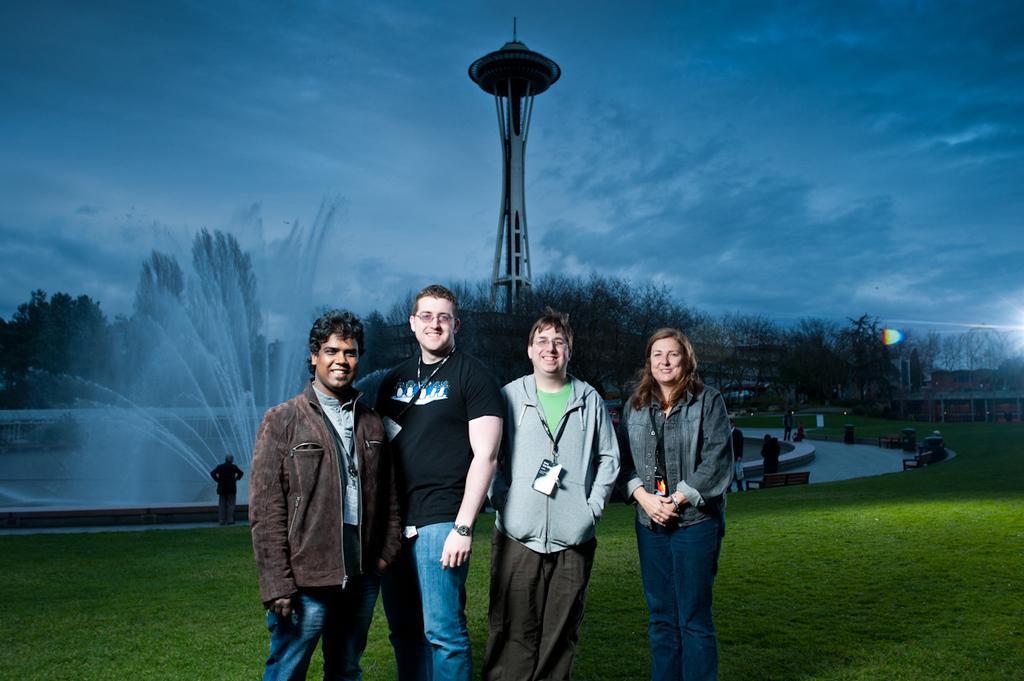Can you describe this image briefly? In the center of the image we can see some persons are standing and smiling. In the middle of the image we can see fountain, water, tower, trees, some persons, benches. At the top of the image we can see the clouds are present in the sky. At the bottom of the image we can see the ground. 